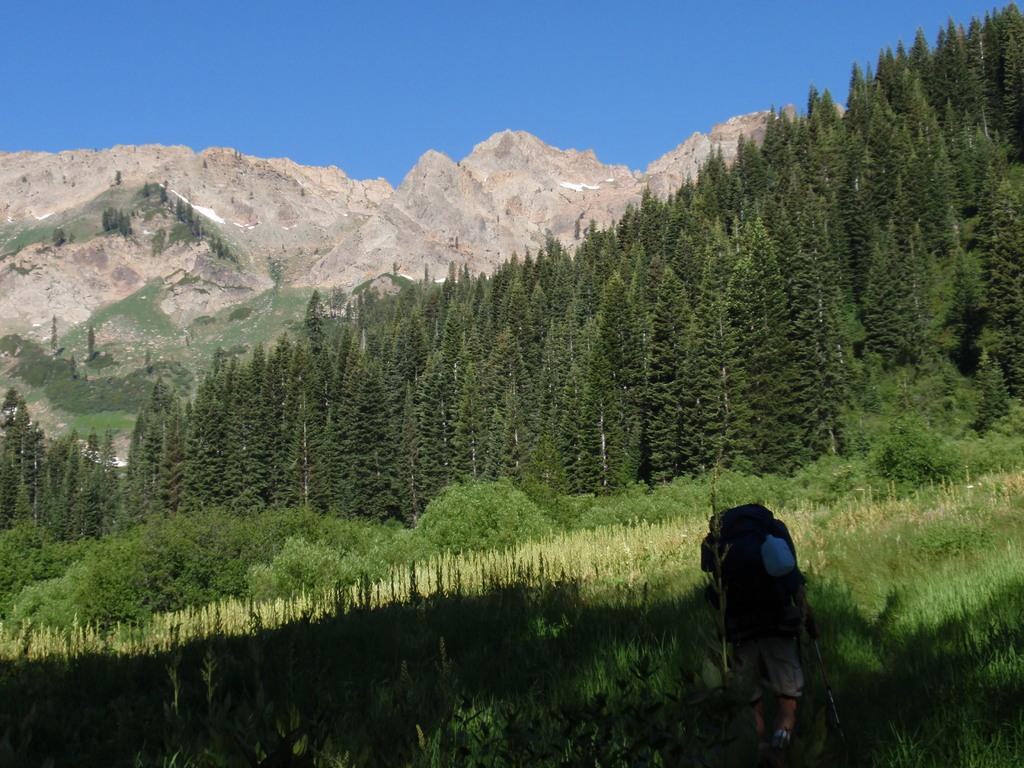Where was the image taken? The image was clicked outside. What can be seen in the middle of the image? There are trees in the middle of the image. What is visible at the top of the image? There is sky visible at the top of the image. What is present at the bottom of the image? There is grass at the bottom of the image, and there is also a person present there. What type of pancake is the person holding in the image? There is no pancake present in the image; the person is standing on grass at the bottom of the image. Can you see any dinosaurs in the image? No, there are no dinosaurs present in the image. 